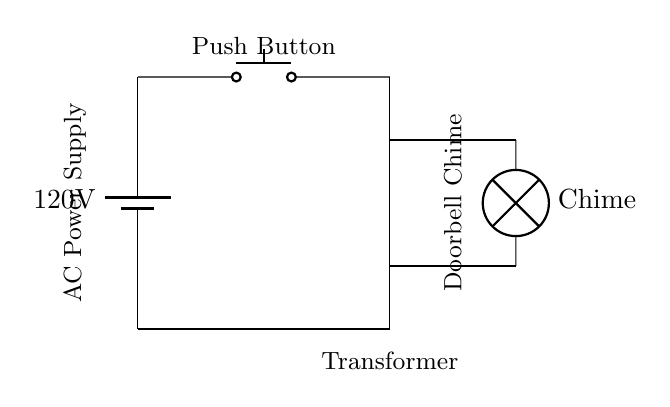What is the power source voltage in this circuit? The power source voltage is indicated at the battery symbol in the circuit diagram, labeled as 120 volts.
Answer: 120 volts What component acts as a switch in this circuit? The switch component in the circuit is represented by the push button, which allows or interrupts the flow of current when pressed.
Answer: Push button What is the main function of the transformer in this circuit? The transformer in this diagram is used to step down the voltage from the power source to a lower voltage suitable for the chime operation.
Answer: Step down voltage Which component produces sound when the button is pressed? The chime, labeled as "Chime" in the circuit, is the component that produces sound when current flows through it, triggered by the push button.
Answer: Chime How many main components are there in this circuit? By counting the visible main components in the circuit diagram—battery, push button, transformer, and chime—we find there are four essential components.
Answer: Four What happens when the push button is pressed? Pressing the push button completes the circuit, allowing current to flow from the battery through the transformer to the chime, making it activate and produce sound.
Answer: Activates chime What type of device is this circuit for? The circuit is specifically for a doorbell, which is meant to signal someone's arrival at a door by producing a chime sound.
Answer: Doorbell 